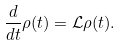<formula> <loc_0><loc_0><loc_500><loc_500>\frac { d } { d t } \rho ( t ) = { \mathcal { L } } \rho ( t ) .</formula> 